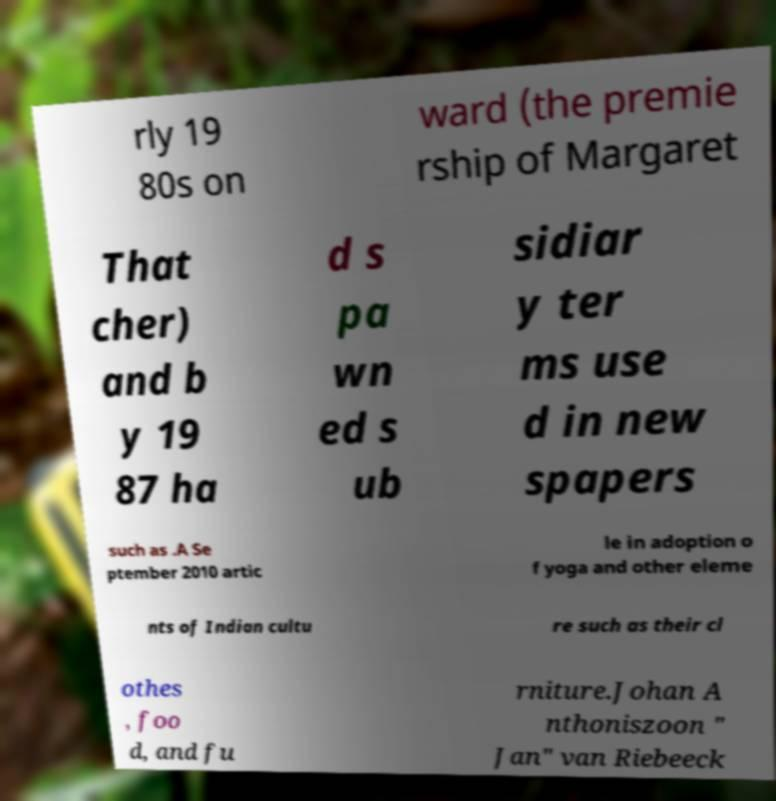Could you extract and type out the text from this image? rly 19 80s on ward (the premie rship of Margaret That cher) and b y 19 87 ha d s pa wn ed s ub sidiar y ter ms use d in new spapers such as .A Se ptember 2010 artic le in adoption o f yoga and other eleme nts of Indian cultu re such as their cl othes , foo d, and fu rniture.Johan A nthoniszoon " Jan" van Riebeeck 